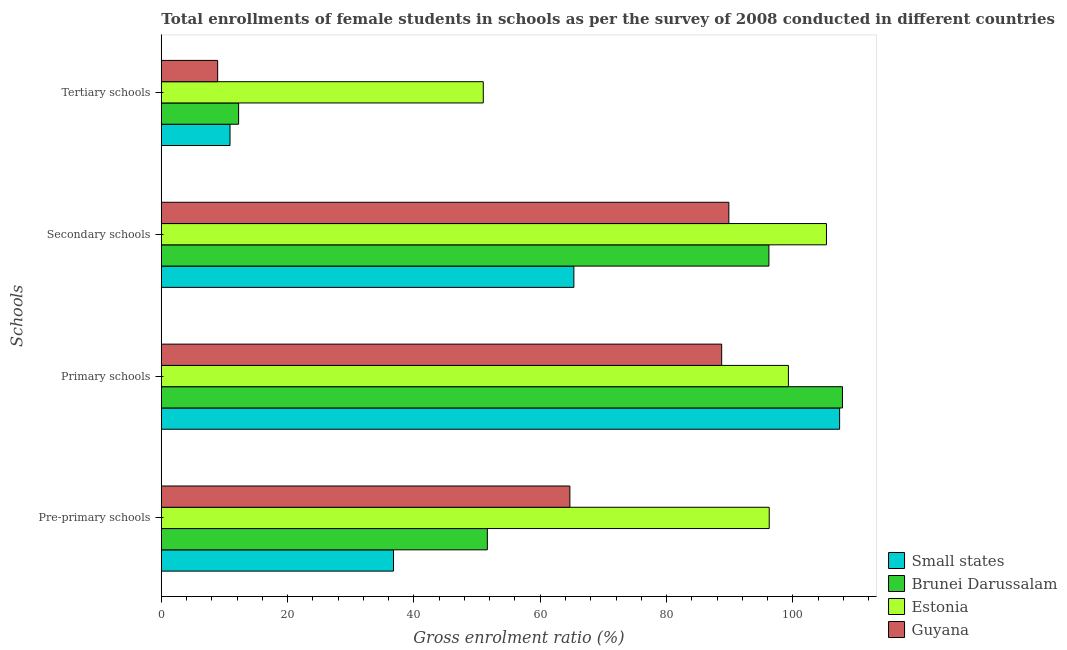How many different coloured bars are there?
Your answer should be very brief. 4. Are the number of bars per tick equal to the number of legend labels?
Provide a succinct answer. Yes. Are the number of bars on each tick of the Y-axis equal?
Your answer should be compact. Yes. How many bars are there on the 1st tick from the top?
Your response must be concise. 4. How many bars are there on the 4th tick from the bottom?
Offer a terse response. 4. What is the label of the 1st group of bars from the top?
Offer a very short reply. Tertiary schools. What is the gross enrolment ratio(female) in pre-primary schools in Small states?
Provide a short and direct response. 36.76. Across all countries, what is the maximum gross enrolment ratio(female) in primary schools?
Your answer should be compact. 107.86. Across all countries, what is the minimum gross enrolment ratio(female) in primary schools?
Your answer should be very brief. 88.73. In which country was the gross enrolment ratio(female) in tertiary schools maximum?
Keep it short and to the point. Estonia. In which country was the gross enrolment ratio(female) in secondary schools minimum?
Provide a short and direct response. Small states. What is the total gross enrolment ratio(female) in pre-primary schools in the graph?
Your answer should be very brief. 249.35. What is the difference between the gross enrolment ratio(female) in secondary schools in Brunei Darussalam and that in Small states?
Provide a short and direct response. 30.88. What is the difference between the gross enrolment ratio(female) in secondary schools in Estonia and the gross enrolment ratio(female) in primary schools in Brunei Darussalam?
Offer a very short reply. -2.54. What is the average gross enrolment ratio(female) in primary schools per country?
Keep it short and to the point. 100.83. What is the difference between the gross enrolment ratio(female) in secondary schools and gross enrolment ratio(female) in tertiary schools in Small states?
Provide a short and direct response. 54.45. In how many countries, is the gross enrolment ratio(female) in secondary schools greater than 12 %?
Keep it short and to the point. 4. What is the ratio of the gross enrolment ratio(female) in primary schools in Small states to that in Estonia?
Offer a terse response. 1.08. What is the difference between the highest and the second highest gross enrolment ratio(female) in pre-primary schools?
Keep it short and to the point. 31.57. What is the difference between the highest and the lowest gross enrolment ratio(female) in primary schools?
Your response must be concise. 19.13. In how many countries, is the gross enrolment ratio(female) in pre-primary schools greater than the average gross enrolment ratio(female) in pre-primary schools taken over all countries?
Your response must be concise. 2. Is the sum of the gross enrolment ratio(female) in primary schools in Small states and Brunei Darussalam greater than the maximum gross enrolment ratio(female) in pre-primary schools across all countries?
Your answer should be compact. Yes. Is it the case that in every country, the sum of the gross enrolment ratio(female) in tertiary schools and gross enrolment ratio(female) in secondary schools is greater than the sum of gross enrolment ratio(female) in pre-primary schools and gross enrolment ratio(female) in primary schools?
Make the answer very short. No. What does the 2nd bar from the top in Primary schools represents?
Your answer should be compact. Estonia. What does the 4th bar from the bottom in Secondary schools represents?
Keep it short and to the point. Guyana. Is it the case that in every country, the sum of the gross enrolment ratio(female) in pre-primary schools and gross enrolment ratio(female) in primary schools is greater than the gross enrolment ratio(female) in secondary schools?
Make the answer very short. Yes. Are all the bars in the graph horizontal?
Make the answer very short. Yes. What is the difference between two consecutive major ticks on the X-axis?
Keep it short and to the point. 20. Are the values on the major ticks of X-axis written in scientific E-notation?
Make the answer very short. No. Where does the legend appear in the graph?
Provide a succinct answer. Bottom right. How many legend labels are there?
Your answer should be compact. 4. How are the legend labels stacked?
Your response must be concise. Vertical. What is the title of the graph?
Give a very brief answer. Total enrollments of female students in schools as per the survey of 2008 conducted in different countries. What is the label or title of the X-axis?
Provide a succinct answer. Gross enrolment ratio (%). What is the label or title of the Y-axis?
Your response must be concise. Schools. What is the Gross enrolment ratio (%) in Small states in Pre-primary schools?
Your answer should be compact. 36.76. What is the Gross enrolment ratio (%) of Brunei Darussalam in Pre-primary schools?
Give a very brief answer. 51.63. What is the Gross enrolment ratio (%) of Estonia in Pre-primary schools?
Your answer should be compact. 96.26. What is the Gross enrolment ratio (%) in Guyana in Pre-primary schools?
Keep it short and to the point. 64.69. What is the Gross enrolment ratio (%) in Small states in Primary schools?
Your answer should be compact. 107.41. What is the Gross enrolment ratio (%) of Brunei Darussalam in Primary schools?
Provide a succinct answer. 107.86. What is the Gross enrolment ratio (%) of Estonia in Primary schools?
Your answer should be very brief. 99.3. What is the Gross enrolment ratio (%) in Guyana in Primary schools?
Keep it short and to the point. 88.73. What is the Gross enrolment ratio (%) in Small states in Secondary schools?
Make the answer very short. 65.33. What is the Gross enrolment ratio (%) of Brunei Darussalam in Secondary schools?
Keep it short and to the point. 96.21. What is the Gross enrolment ratio (%) of Estonia in Secondary schools?
Your response must be concise. 105.33. What is the Gross enrolment ratio (%) in Guyana in Secondary schools?
Provide a short and direct response. 89.87. What is the Gross enrolment ratio (%) of Small states in Tertiary schools?
Provide a succinct answer. 10.88. What is the Gross enrolment ratio (%) in Brunei Darussalam in Tertiary schools?
Your answer should be compact. 12.24. What is the Gross enrolment ratio (%) of Estonia in Tertiary schools?
Offer a terse response. 50.98. What is the Gross enrolment ratio (%) in Guyana in Tertiary schools?
Keep it short and to the point. 8.92. Across all Schools, what is the maximum Gross enrolment ratio (%) of Small states?
Ensure brevity in your answer.  107.41. Across all Schools, what is the maximum Gross enrolment ratio (%) in Brunei Darussalam?
Keep it short and to the point. 107.86. Across all Schools, what is the maximum Gross enrolment ratio (%) in Estonia?
Provide a short and direct response. 105.33. Across all Schools, what is the maximum Gross enrolment ratio (%) in Guyana?
Offer a very short reply. 89.87. Across all Schools, what is the minimum Gross enrolment ratio (%) of Small states?
Give a very brief answer. 10.88. Across all Schools, what is the minimum Gross enrolment ratio (%) of Brunei Darussalam?
Your answer should be compact. 12.24. Across all Schools, what is the minimum Gross enrolment ratio (%) in Estonia?
Make the answer very short. 50.98. Across all Schools, what is the minimum Gross enrolment ratio (%) of Guyana?
Ensure brevity in your answer.  8.92. What is the total Gross enrolment ratio (%) in Small states in the graph?
Provide a short and direct response. 220.38. What is the total Gross enrolment ratio (%) in Brunei Darussalam in the graph?
Give a very brief answer. 267.94. What is the total Gross enrolment ratio (%) in Estonia in the graph?
Your answer should be compact. 351.87. What is the total Gross enrolment ratio (%) in Guyana in the graph?
Your response must be concise. 252.22. What is the difference between the Gross enrolment ratio (%) in Small states in Pre-primary schools and that in Primary schools?
Keep it short and to the point. -70.64. What is the difference between the Gross enrolment ratio (%) in Brunei Darussalam in Pre-primary schools and that in Primary schools?
Your answer should be very brief. -56.24. What is the difference between the Gross enrolment ratio (%) in Estonia in Pre-primary schools and that in Primary schools?
Make the answer very short. -3.03. What is the difference between the Gross enrolment ratio (%) in Guyana in Pre-primary schools and that in Primary schools?
Provide a succinct answer. -24.04. What is the difference between the Gross enrolment ratio (%) of Small states in Pre-primary schools and that in Secondary schools?
Make the answer very short. -28.57. What is the difference between the Gross enrolment ratio (%) of Brunei Darussalam in Pre-primary schools and that in Secondary schools?
Offer a terse response. -44.59. What is the difference between the Gross enrolment ratio (%) in Estonia in Pre-primary schools and that in Secondary schools?
Your response must be concise. -9.06. What is the difference between the Gross enrolment ratio (%) of Guyana in Pre-primary schools and that in Secondary schools?
Keep it short and to the point. -25.17. What is the difference between the Gross enrolment ratio (%) in Small states in Pre-primary schools and that in Tertiary schools?
Keep it short and to the point. 25.89. What is the difference between the Gross enrolment ratio (%) in Brunei Darussalam in Pre-primary schools and that in Tertiary schools?
Ensure brevity in your answer.  39.39. What is the difference between the Gross enrolment ratio (%) in Estonia in Pre-primary schools and that in Tertiary schools?
Keep it short and to the point. 45.28. What is the difference between the Gross enrolment ratio (%) of Guyana in Pre-primary schools and that in Tertiary schools?
Your response must be concise. 55.77. What is the difference between the Gross enrolment ratio (%) in Small states in Primary schools and that in Secondary schools?
Offer a terse response. 42.08. What is the difference between the Gross enrolment ratio (%) in Brunei Darussalam in Primary schools and that in Secondary schools?
Provide a short and direct response. 11.65. What is the difference between the Gross enrolment ratio (%) in Estonia in Primary schools and that in Secondary schools?
Your answer should be very brief. -6.03. What is the difference between the Gross enrolment ratio (%) of Guyana in Primary schools and that in Secondary schools?
Provide a succinct answer. -1.14. What is the difference between the Gross enrolment ratio (%) in Small states in Primary schools and that in Tertiary schools?
Give a very brief answer. 96.53. What is the difference between the Gross enrolment ratio (%) in Brunei Darussalam in Primary schools and that in Tertiary schools?
Your answer should be compact. 95.62. What is the difference between the Gross enrolment ratio (%) of Estonia in Primary schools and that in Tertiary schools?
Your answer should be compact. 48.31. What is the difference between the Gross enrolment ratio (%) of Guyana in Primary schools and that in Tertiary schools?
Keep it short and to the point. 79.81. What is the difference between the Gross enrolment ratio (%) of Small states in Secondary schools and that in Tertiary schools?
Your answer should be very brief. 54.45. What is the difference between the Gross enrolment ratio (%) in Brunei Darussalam in Secondary schools and that in Tertiary schools?
Offer a terse response. 83.97. What is the difference between the Gross enrolment ratio (%) in Estonia in Secondary schools and that in Tertiary schools?
Offer a very short reply. 54.34. What is the difference between the Gross enrolment ratio (%) of Guyana in Secondary schools and that in Tertiary schools?
Offer a terse response. 80.95. What is the difference between the Gross enrolment ratio (%) in Small states in Pre-primary schools and the Gross enrolment ratio (%) in Brunei Darussalam in Primary schools?
Keep it short and to the point. -71.1. What is the difference between the Gross enrolment ratio (%) in Small states in Pre-primary schools and the Gross enrolment ratio (%) in Estonia in Primary schools?
Make the answer very short. -62.54. What is the difference between the Gross enrolment ratio (%) of Small states in Pre-primary schools and the Gross enrolment ratio (%) of Guyana in Primary schools?
Keep it short and to the point. -51.97. What is the difference between the Gross enrolment ratio (%) of Brunei Darussalam in Pre-primary schools and the Gross enrolment ratio (%) of Estonia in Primary schools?
Your answer should be very brief. -47.67. What is the difference between the Gross enrolment ratio (%) of Brunei Darussalam in Pre-primary schools and the Gross enrolment ratio (%) of Guyana in Primary schools?
Offer a terse response. -37.11. What is the difference between the Gross enrolment ratio (%) in Estonia in Pre-primary schools and the Gross enrolment ratio (%) in Guyana in Primary schools?
Your response must be concise. 7.53. What is the difference between the Gross enrolment ratio (%) of Small states in Pre-primary schools and the Gross enrolment ratio (%) of Brunei Darussalam in Secondary schools?
Your response must be concise. -59.45. What is the difference between the Gross enrolment ratio (%) in Small states in Pre-primary schools and the Gross enrolment ratio (%) in Estonia in Secondary schools?
Offer a very short reply. -68.56. What is the difference between the Gross enrolment ratio (%) in Small states in Pre-primary schools and the Gross enrolment ratio (%) in Guyana in Secondary schools?
Offer a terse response. -53.11. What is the difference between the Gross enrolment ratio (%) in Brunei Darussalam in Pre-primary schools and the Gross enrolment ratio (%) in Estonia in Secondary schools?
Ensure brevity in your answer.  -53.7. What is the difference between the Gross enrolment ratio (%) in Brunei Darussalam in Pre-primary schools and the Gross enrolment ratio (%) in Guyana in Secondary schools?
Provide a short and direct response. -38.24. What is the difference between the Gross enrolment ratio (%) in Estonia in Pre-primary schools and the Gross enrolment ratio (%) in Guyana in Secondary schools?
Make the answer very short. 6.4. What is the difference between the Gross enrolment ratio (%) in Small states in Pre-primary schools and the Gross enrolment ratio (%) in Brunei Darussalam in Tertiary schools?
Make the answer very short. 24.52. What is the difference between the Gross enrolment ratio (%) of Small states in Pre-primary schools and the Gross enrolment ratio (%) of Estonia in Tertiary schools?
Offer a very short reply. -14.22. What is the difference between the Gross enrolment ratio (%) in Small states in Pre-primary schools and the Gross enrolment ratio (%) in Guyana in Tertiary schools?
Your answer should be very brief. 27.84. What is the difference between the Gross enrolment ratio (%) in Brunei Darussalam in Pre-primary schools and the Gross enrolment ratio (%) in Estonia in Tertiary schools?
Make the answer very short. 0.64. What is the difference between the Gross enrolment ratio (%) in Brunei Darussalam in Pre-primary schools and the Gross enrolment ratio (%) in Guyana in Tertiary schools?
Your response must be concise. 42.7. What is the difference between the Gross enrolment ratio (%) of Estonia in Pre-primary schools and the Gross enrolment ratio (%) of Guyana in Tertiary schools?
Ensure brevity in your answer.  87.34. What is the difference between the Gross enrolment ratio (%) in Small states in Primary schools and the Gross enrolment ratio (%) in Brunei Darussalam in Secondary schools?
Your answer should be compact. 11.19. What is the difference between the Gross enrolment ratio (%) of Small states in Primary schools and the Gross enrolment ratio (%) of Estonia in Secondary schools?
Your response must be concise. 2.08. What is the difference between the Gross enrolment ratio (%) of Small states in Primary schools and the Gross enrolment ratio (%) of Guyana in Secondary schools?
Your response must be concise. 17.54. What is the difference between the Gross enrolment ratio (%) in Brunei Darussalam in Primary schools and the Gross enrolment ratio (%) in Estonia in Secondary schools?
Offer a very short reply. 2.54. What is the difference between the Gross enrolment ratio (%) in Brunei Darussalam in Primary schools and the Gross enrolment ratio (%) in Guyana in Secondary schools?
Provide a short and direct response. 17.99. What is the difference between the Gross enrolment ratio (%) of Estonia in Primary schools and the Gross enrolment ratio (%) of Guyana in Secondary schools?
Your answer should be compact. 9.43. What is the difference between the Gross enrolment ratio (%) of Small states in Primary schools and the Gross enrolment ratio (%) of Brunei Darussalam in Tertiary schools?
Ensure brevity in your answer.  95.17. What is the difference between the Gross enrolment ratio (%) in Small states in Primary schools and the Gross enrolment ratio (%) in Estonia in Tertiary schools?
Your answer should be compact. 56.42. What is the difference between the Gross enrolment ratio (%) in Small states in Primary schools and the Gross enrolment ratio (%) in Guyana in Tertiary schools?
Your answer should be very brief. 98.48. What is the difference between the Gross enrolment ratio (%) of Brunei Darussalam in Primary schools and the Gross enrolment ratio (%) of Estonia in Tertiary schools?
Provide a succinct answer. 56.88. What is the difference between the Gross enrolment ratio (%) in Brunei Darussalam in Primary schools and the Gross enrolment ratio (%) in Guyana in Tertiary schools?
Make the answer very short. 98.94. What is the difference between the Gross enrolment ratio (%) of Estonia in Primary schools and the Gross enrolment ratio (%) of Guyana in Tertiary schools?
Your answer should be compact. 90.38. What is the difference between the Gross enrolment ratio (%) in Small states in Secondary schools and the Gross enrolment ratio (%) in Brunei Darussalam in Tertiary schools?
Your answer should be compact. 53.09. What is the difference between the Gross enrolment ratio (%) of Small states in Secondary schools and the Gross enrolment ratio (%) of Estonia in Tertiary schools?
Give a very brief answer. 14.35. What is the difference between the Gross enrolment ratio (%) in Small states in Secondary schools and the Gross enrolment ratio (%) in Guyana in Tertiary schools?
Ensure brevity in your answer.  56.41. What is the difference between the Gross enrolment ratio (%) in Brunei Darussalam in Secondary schools and the Gross enrolment ratio (%) in Estonia in Tertiary schools?
Your answer should be very brief. 45.23. What is the difference between the Gross enrolment ratio (%) in Brunei Darussalam in Secondary schools and the Gross enrolment ratio (%) in Guyana in Tertiary schools?
Keep it short and to the point. 87.29. What is the difference between the Gross enrolment ratio (%) in Estonia in Secondary schools and the Gross enrolment ratio (%) in Guyana in Tertiary schools?
Provide a succinct answer. 96.4. What is the average Gross enrolment ratio (%) in Small states per Schools?
Provide a succinct answer. 55.09. What is the average Gross enrolment ratio (%) of Brunei Darussalam per Schools?
Make the answer very short. 66.99. What is the average Gross enrolment ratio (%) in Estonia per Schools?
Offer a very short reply. 87.97. What is the average Gross enrolment ratio (%) in Guyana per Schools?
Ensure brevity in your answer.  63.05. What is the difference between the Gross enrolment ratio (%) in Small states and Gross enrolment ratio (%) in Brunei Darussalam in Pre-primary schools?
Give a very brief answer. -14.86. What is the difference between the Gross enrolment ratio (%) of Small states and Gross enrolment ratio (%) of Estonia in Pre-primary schools?
Provide a short and direct response. -59.5. What is the difference between the Gross enrolment ratio (%) in Small states and Gross enrolment ratio (%) in Guyana in Pre-primary schools?
Provide a succinct answer. -27.93. What is the difference between the Gross enrolment ratio (%) in Brunei Darussalam and Gross enrolment ratio (%) in Estonia in Pre-primary schools?
Your answer should be compact. -44.64. What is the difference between the Gross enrolment ratio (%) in Brunei Darussalam and Gross enrolment ratio (%) in Guyana in Pre-primary schools?
Your answer should be compact. -13.07. What is the difference between the Gross enrolment ratio (%) in Estonia and Gross enrolment ratio (%) in Guyana in Pre-primary schools?
Offer a very short reply. 31.57. What is the difference between the Gross enrolment ratio (%) in Small states and Gross enrolment ratio (%) in Brunei Darussalam in Primary schools?
Your response must be concise. -0.46. What is the difference between the Gross enrolment ratio (%) of Small states and Gross enrolment ratio (%) of Estonia in Primary schools?
Provide a short and direct response. 8.11. What is the difference between the Gross enrolment ratio (%) in Small states and Gross enrolment ratio (%) in Guyana in Primary schools?
Keep it short and to the point. 18.67. What is the difference between the Gross enrolment ratio (%) of Brunei Darussalam and Gross enrolment ratio (%) of Estonia in Primary schools?
Your answer should be compact. 8.56. What is the difference between the Gross enrolment ratio (%) of Brunei Darussalam and Gross enrolment ratio (%) of Guyana in Primary schools?
Make the answer very short. 19.13. What is the difference between the Gross enrolment ratio (%) in Estonia and Gross enrolment ratio (%) in Guyana in Primary schools?
Offer a very short reply. 10.57. What is the difference between the Gross enrolment ratio (%) of Small states and Gross enrolment ratio (%) of Brunei Darussalam in Secondary schools?
Ensure brevity in your answer.  -30.88. What is the difference between the Gross enrolment ratio (%) of Small states and Gross enrolment ratio (%) of Estonia in Secondary schools?
Ensure brevity in your answer.  -40. What is the difference between the Gross enrolment ratio (%) in Small states and Gross enrolment ratio (%) in Guyana in Secondary schools?
Your answer should be very brief. -24.54. What is the difference between the Gross enrolment ratio (%) in Brunei Darussalam and Gross enrolment ratio (%) in Estonia in Secondary schools?
Provide a succinct answer. -9.11. What is the difference between the Gross enrolment ratio (%) of Brunei Darussalam and Gross enrolment ratio (%) of Guyana in Secondary schools?
Provide a succinct answer. 6.34. What is the difference between the Gross enrolment ratio (%) in Estonia and Gross enrolment ratio (%) in Guyana in Secondary schools?
Provide a short and direct response. 15.46. What is the difference between the Gross enrolment ratio (%) of Small states and Gross enrolment ratio (%) of Brunei Darussalam in Tertiary schools?
Keep it short and to the point. -1.36. What is the difference between the Gross enrolment ratio (%) in Small states and Gross enrolment ratio (%) in Estonia in Tertiary schools?
Make the answer very short. -40.11. What is the difference between the Gross enrolment ratio (%) of Small states and Gross enrolment ratio (%) of Guyana in Tertiary schools?
Your response must be concise. 1.95. What is the difference between the Gross enrolment ratio (%) in Brunei Darussalam and Gross enrolment ratio (%) in Estonia in Tertiary schools?
Offer a very short reply. -38.74. What is the difference between the Gross enrolment ratio (%) of Brunei Darussalam and Gross enrolment ratio (%) of Guyana in Tertiary schools?
Keep it short and to the point. 3.32. What is the difference between the Gross enrolment ratio (%) in Estonia and Gross enrolment ratio (%) in Guyana in Tertiary schools?
Your response must be concise. 42.06. What is the ratio of the Gross enrolment ratio (%) in Small states in Pre-primary schools to that in Primary schools?
Keep it short and to the point. 0.34. What is the ratio of the Gross enrolment ratio (%) in Brunei Darussalam in Pre-primary schools to that in Primary schools?
Keep it short and to the point. 0.48. What is the ratio of the Gross enrolment ratio (%) of Estonia in Pre-primary schools to that in Primary schools?
Provide a short and direct response. 0.97. What is the ratio of the Gross enrolment ratio (%) in Guyana in Pre-primary schools to that in Primary schools?
Ensure brevity in your answer.  0.73. What is the ratio of the Gross enrolment ratio (%) of Small states in Pre-primary schools to that in Secondary schools?
Ensure brevity in your answer.  0.56. What is the ratio of the Gross enrolment ratio (%) of Brunei Darussalam in Pre-primary schools to that in Secondary schools?
Provide a short and direct response. 0.54. What is the ratio of the Gross enrolment ratio (%) of Estonia in Pre-primary schools to that in Secondary schools?
Provide a succinct answer. 0.91. What is the ratio of the Gross enrolment ratio (%) of Guyana in Pre-primary schools to that in Secondary schools?
Offer a very short reply. 0.72. What is the ratio of the Gross enrolment ratio (%) of Small states in Pre-primary schools to that in Tertiary schools?
Offer a very short reply. 3.38. What is the ratio of the Gross enrolment ratio (%) of Brunei Darussalam in Pre-primary schools to that in Tertiary schools?
Provide a succinct answer. 4.22. What is the ratio of the Gross enrolment ratio (%) of Estonia in Pre-primary schools to that in Tertiary schools?
Offer a very short reply. 1.89. What is the ratio of the Gross enrolment ratio (%) in Guyana in Pre-primary schools to that in Tertiary schools?
Provide a short and direct response. 7.25. What is the ratio of the Gross enrolment ratio (%) of Small states in Primary schools to that in Secondary schools?
Your answer should be compact. 1.64. What is the ratio of the Gross enrolment ratio (%) in Brunei Darussalam in Primary schools to that in Secondary schools?
Provide a succinct answer. 1.12. What is the ratio of the Gross enrolment ratio (%) of Estonia in Primary schools to that in Secondary schools?
Your answer should be compact. 0.94. What is the ratio of the Gross enrolment ratio (%) of Guyana in Primary schools to that in Secondary schools?
Provide a succinct answer. 0.99. What is the ratio of the Gross enrolment ratio (%) of Small states in Primary schools to that in Tertiary schools?
Your response must be concise. 9.87. What is the ratio of the Gross enrolment ratio (%) of Brunei Darussalam in Primary schools to that in Tertiary schools?
Offer a terse response. 8.81. What is the ratio of the Gross enrolment ratio (%) in Estonia in Primary schools to that in Tertiary schools?
Offer a terse response. 1.95. What is the ratio of the Gross enrolment ratio (%) of Guyana in Primary schools to that in Tertiary schools?
Offer a terse response. 9.94. What is the ratio of the Gross enrolment ratio (%) in Small states in Secondary schools to that in Tertiary schools?
Keep it short and to the point. 6.01. What is the ratio of the Gross enrolment ratio (%) in Brunei Darussalam in Secondary schools to that in Tertiary schools?
Provide a succinct answer. 7.86. What is the ratio of the Gross enrolment ratio (%) in Estonia in Secondary schools to that in Tertiary schools?
Keep it short and to the point. 2.07. What is the ratio of the Gross enrolment ratio (%) of Guyana in Secondary schools to that in Tertiary schools?
Provide a succinct answer. 10.07. What is the difference between the highest and the second highest Gross enrolment ratio (%) in Small states?
Keep it short and to the point. 42.08. What is the difference between the highest and the second highest Gross enrolment ratio (%) of Brunei Darussalam?
Keep it short and to the point. 11.65. What is the difference between the highest and the second highest Gross enrolment ratio (%) of Estonia?
Keep it short and to the point. 6.03. What is the difference between the highest and the second highest Gross enrolment ratio (%) in Guyana?
Your answer should be very brief. 1.14. What is the difference between the highest and the lowest Gross enrolment ratio (%) of Small states?
Provide a succinct answer. 96.53. What is the difference between the highest and the lowest Gross enrolment ratio (%) in Brunei Darussalam?
Give a very brief answer. 95.62. What is the difference between the highest and the lowest Gross enrolment ratio (%) in Estonia?
Offer a terse response. 54.34. What is the difference between the highest and the lowest Gross enrolment ratio (%) of Guyana?
Ensure brevity in your answer.  80.95. 